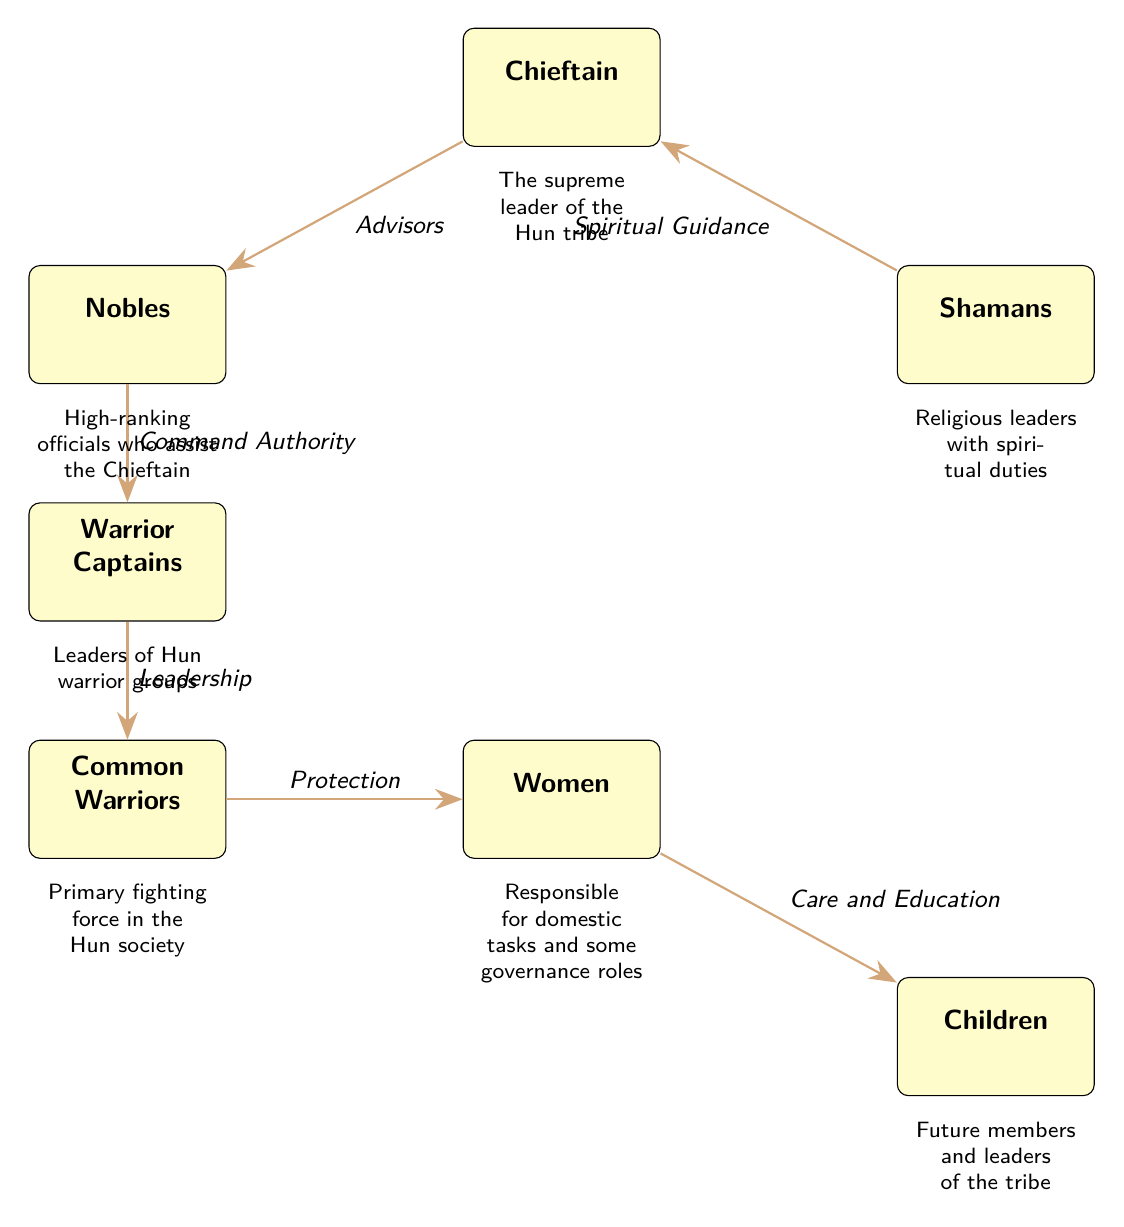What is the highest rank in Hun society as depicted in the diagram? The diagram identifies the "Chieftain" at the top position, indicating that he holds the highest rank in Hun society.
Answer: Chieftain How many main hierarchical roles are represented in the Hun society diagram? The diagram shows a total of six main roles: Chieftain, Nobles, Shamans, Warrior Captains, Common Warriors, Women, and Children.
Answer: Six What role provides spiritual guidance to the Chieftain? The diagram indicates that "Shamans" are responsible for providing spiritual guidance to the Chieftain, as shown by the connecting edge labeled "Spiritual Guidance."
Answer: Shamans Who are responsible for the protection of women in the Hun society? According to the diagram, the "Common Warriors" are tasked with the protection of women, as indicated by the edge that flows from Common Warriors to Women labeled "Protection."
Answer: Common Warriors What is the role of "Women" in Hun society as described in the diagram? The diagram assigns the role of "Women" to domestic tasks and some governance roles, as explicitly stated in the description below the Women node.
Answer: Domestic tasks and governance Which node is directly connected to "Warrior Captains" in terms of command authority? The diagram shows an edge pointing from "Nobles" to "Warrior Captains," indicating that Nobles have command authority over the Warrior Captains.
Answer: Nobles What do "Children" symbolize in the Hun society hierarchy? The diagram notes that “Children” represent future members and leaders of the tribe, highlighting their importance in societal continuity.
Answer: Future members and leaders Describe the flow of authority from the Chieftain to the Common Warriors. The authority flows from the Chieftain to the Nobles, who then command the Warrior Captains, who lead the Common Warriors. This represents a clear command structure where the Chieftain ultimately exercises the highest authority.
Answer: Chieftain → Nobles → Warrior Captains → Common Warriors What is the relationship between Women and Children in Hun society according to the diagram? The diagram illustrates that Women have the role of "Care and Education" for Children, establishing a nurturing relationship as indicated by the connecting edge labeled "Care and Education."
Answer: Care and Education 